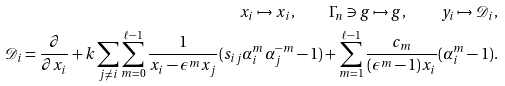Convert formula to latex. <formula><loc_0><loc_0><loc_500><loc_500>x _ { i } \mapsto x _ { i } , \quad \Gamma _ { n } \ni g \mapsto g , \quad y _ { i } \mapsto \mathcal { D } _ { i } , \\ \mathcal { D } _ { i } = \frac { \partial } { \partial x _ { i } } + k \sum _ { j \ne i } \sum _ { m = 0 } ^ { \ell - 1 } \frac { 1 } { x _ { i } - \epsilon ^ { m } x _ { j } } ( s _ { i j } \alpha _ { i } ^ { m } \alpha _ { j } ^ { - m } - 1 ) + \sum _ { m = 1 } ^ { \ell - 1 } \frac { c _ { m } } { ( \epsilon ^ { m } - 1 ) x _ { i } } ( \alpha _ { i } ^ { m } - 1 ) .</formula> 